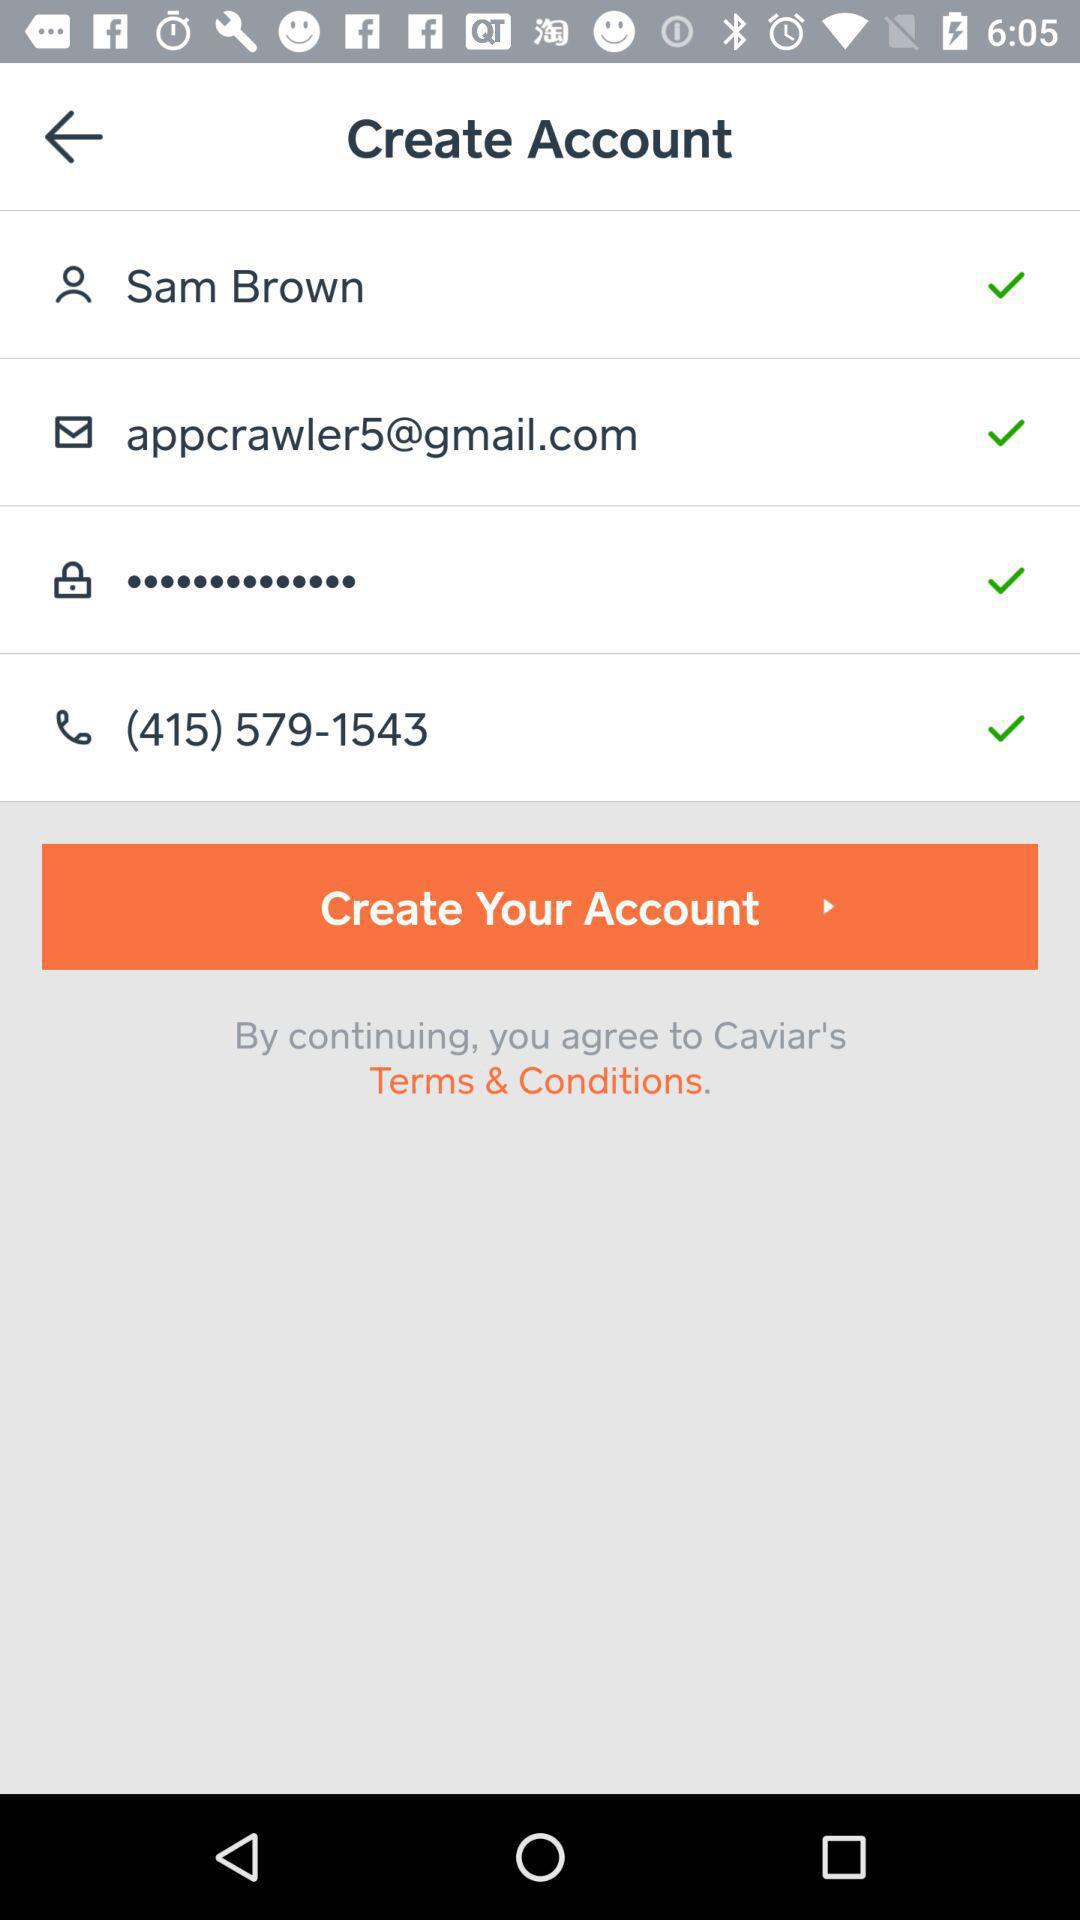What is the user name? The user name is Sam Brown. 